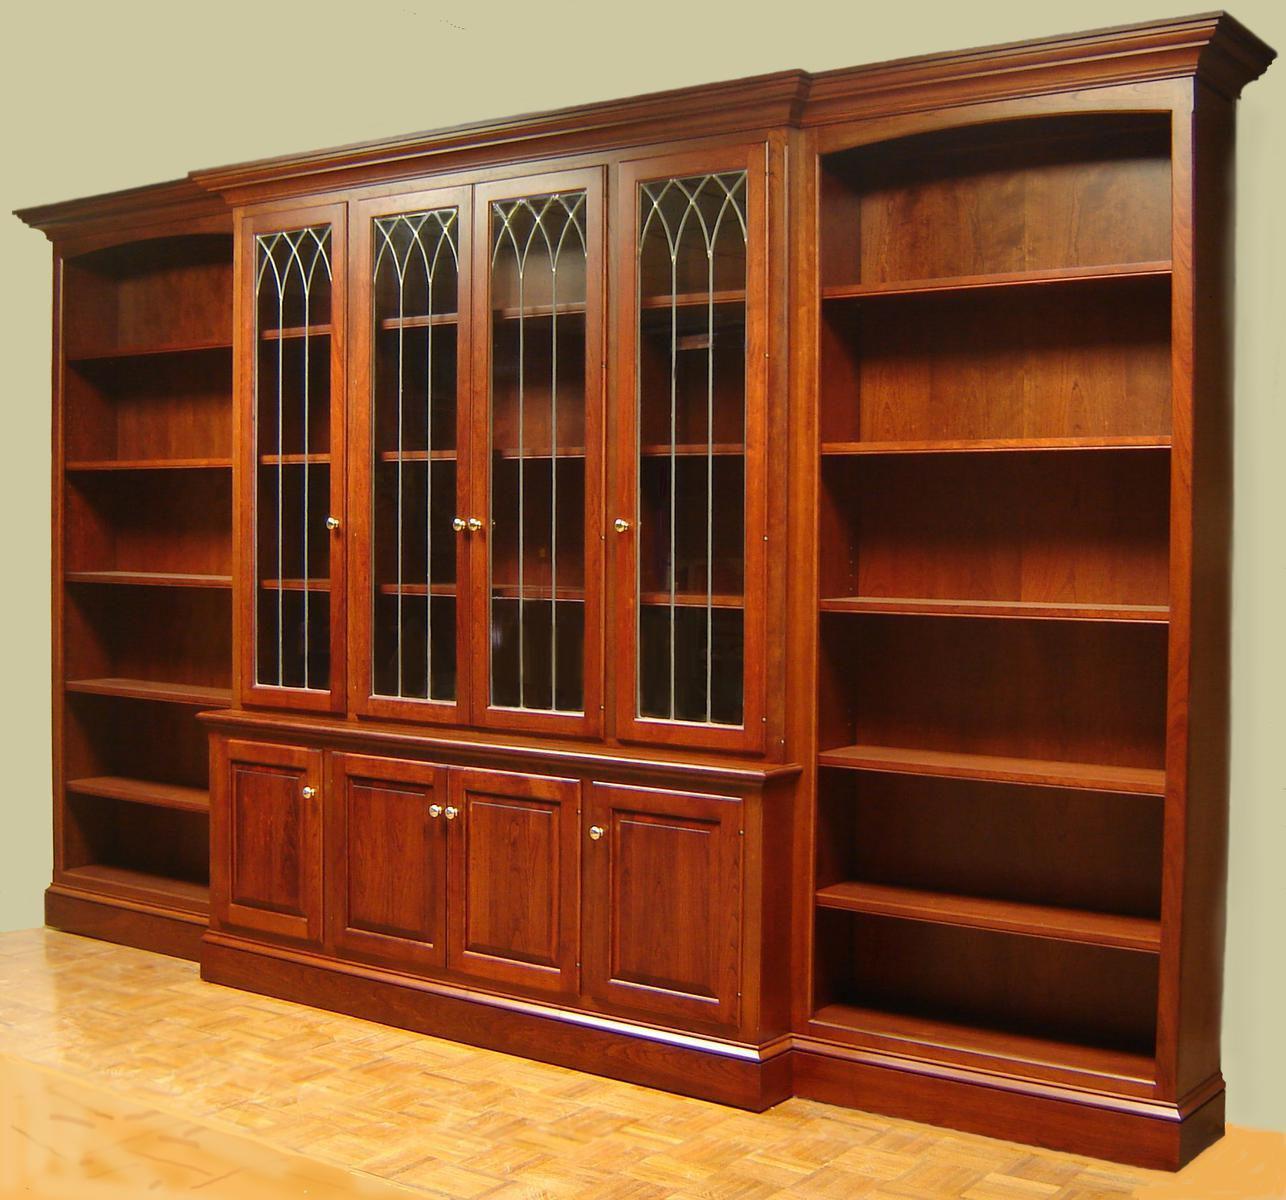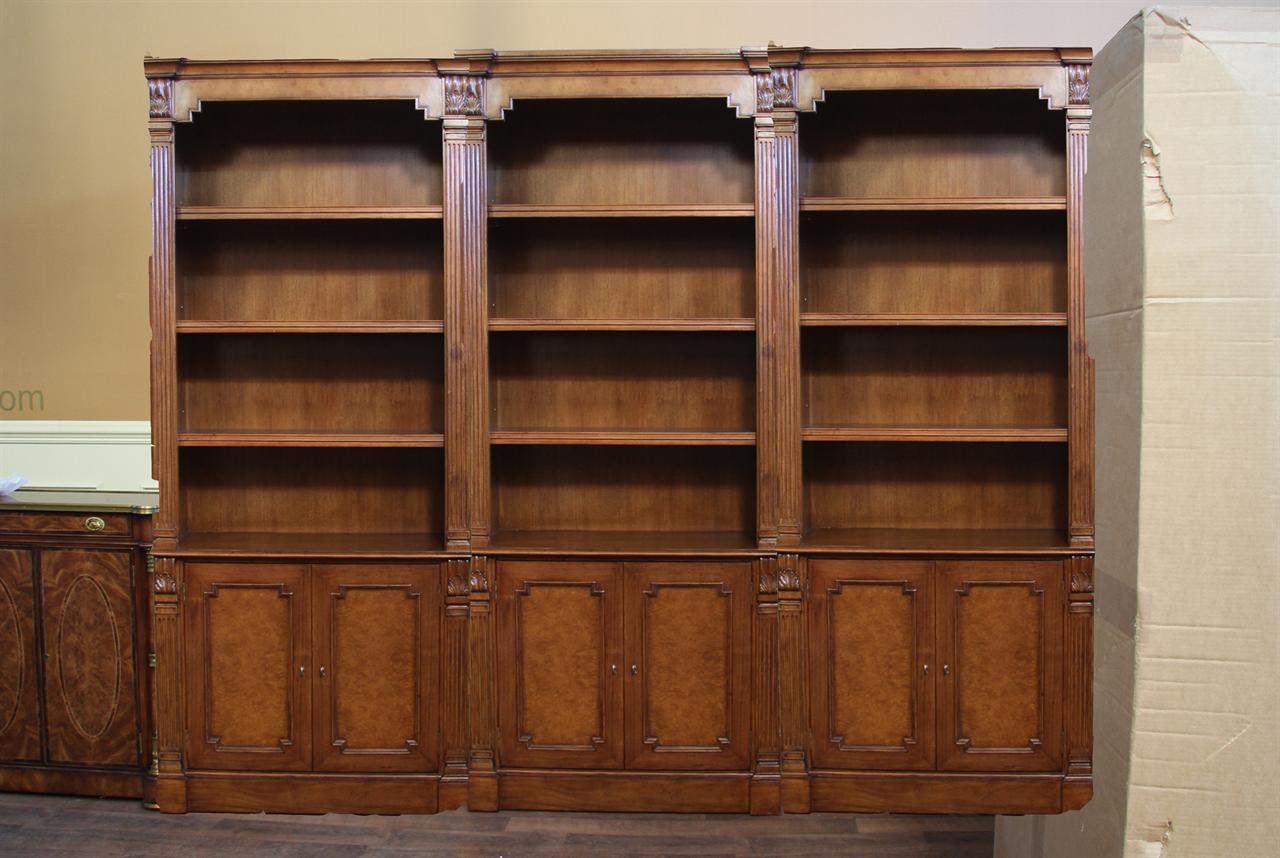The first image is the image on the left, the second image is the image on the right. For the images shown, is this caption "The shelves have no objects resting on them." true? Answer yes or no. Yes. The first image is the image on the left, the second image is the image on the right. For the images shown, is this caption "A bookcase in one image has three side-by-side upper shelf units over six solid doors." true? Answer yes or no. Yes. 